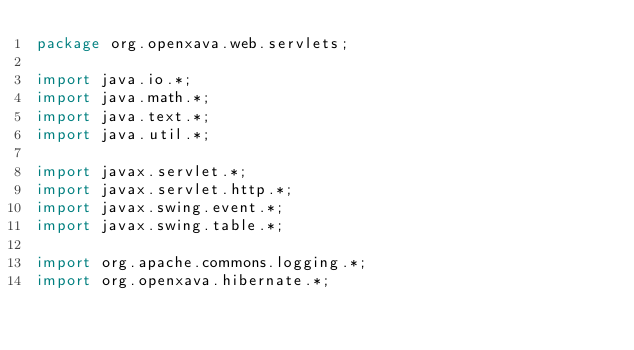<code> <loc_0><loc_0><loc_500><loc_500><_Java_>package org.openxava.web.servlets;

import java.io.*;
import java.math.*;
import java.text.*;
import java.util.*;

import javax.servlet.*;
import javax.servlet.http.*;
import javax.swing.event.*;
import javax.swing.table.*;

import org.apache.commons.logging.*;
import org.openxava.hibernate.*;</code> 